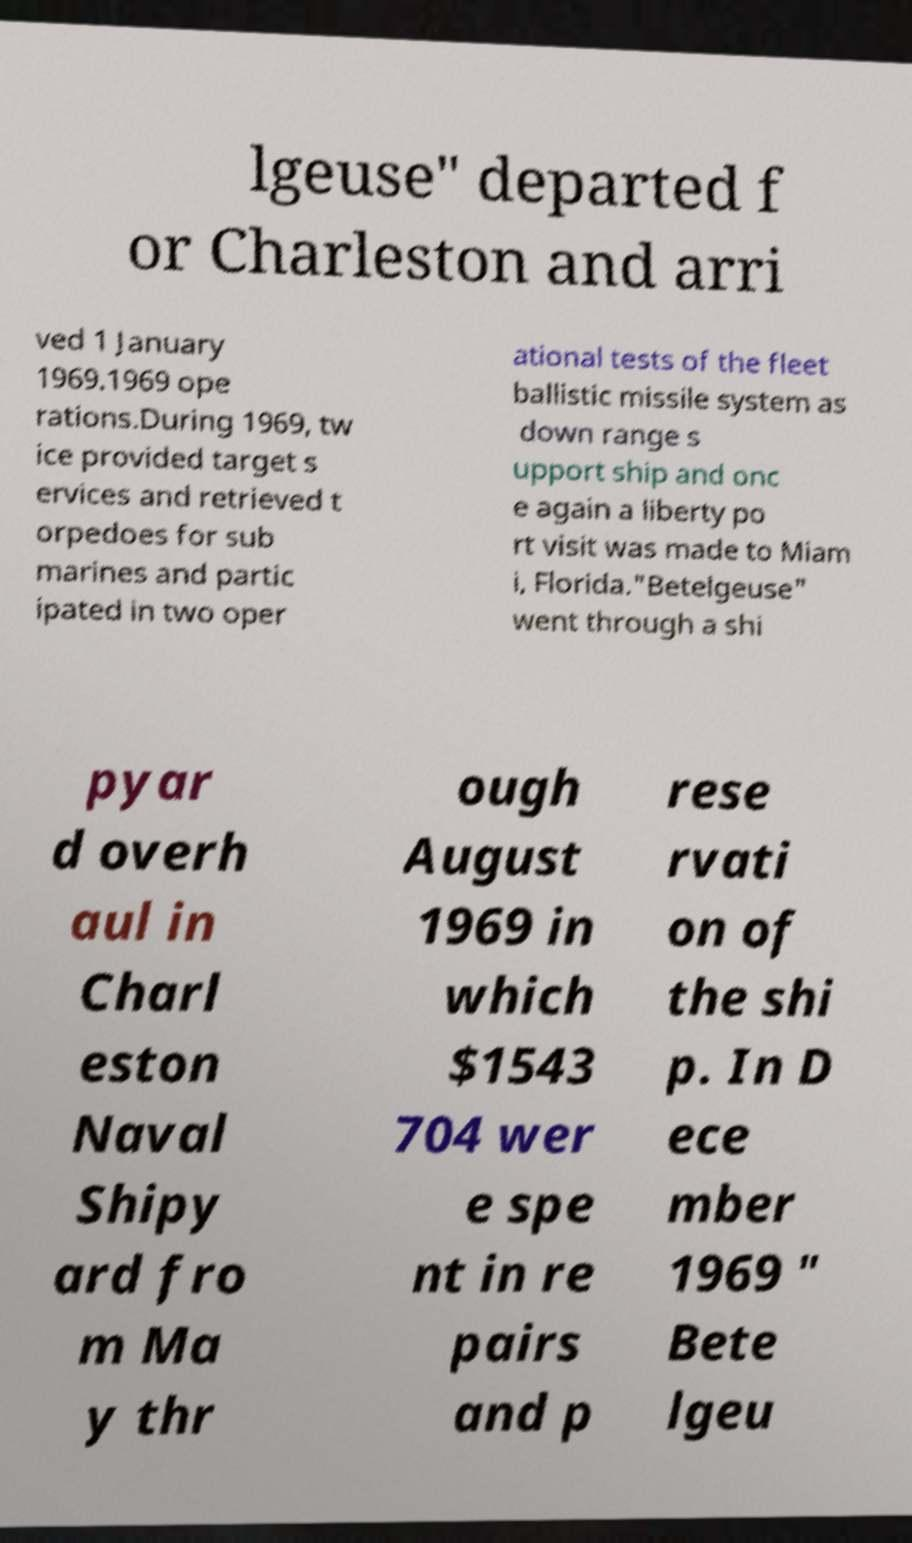There's text embedded in this image that I need extracted. Can you transcribe it verbatim? lgeuse" departed f or Charleston and arri ved 1 January 1969.1969 ope rations.During 1969, tw ice provided target s ervices and retrieved t orpedoes for sub marines and partic ipated in two oper ational tests of the fleet ballistic missile system as down range s upport ship and onc e again a liberty po rt visit was made to Miam i, Florida."Betelgeuse" went through a shi pyar d overh aul in Charl eston Naval Shipy ard fro m Ma y thr ough August 1969 in which $1543 704 wer e spe nt in re pairs and p rese rvati on of the shi p. In D ece mber 1969 " Bete lgeu 